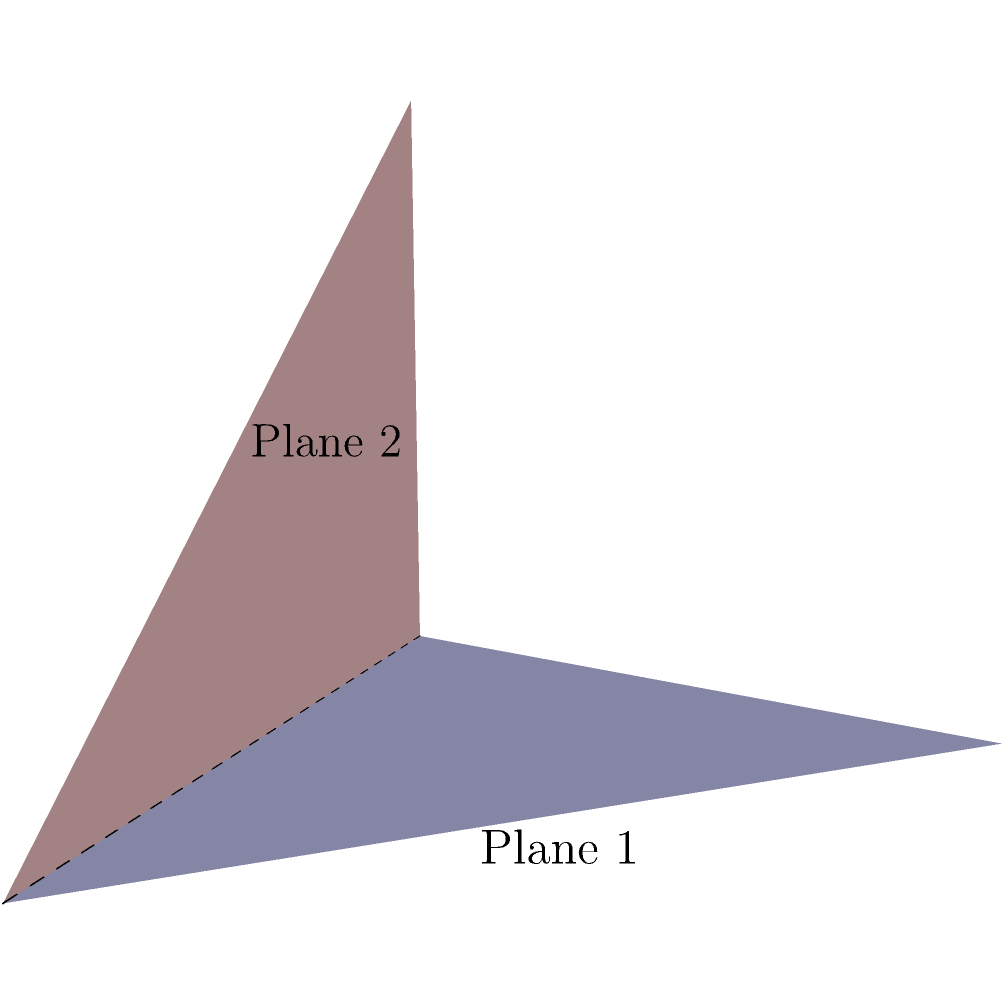In the diagram, two planes intersect along a line. Given that the normal vectors to Plane 1 and Plane 2 are $\vec{n_1} = (0, 0, 1)$ and $\vec{n_2} = (0, 1, 0)$ respectively, determine the angle $\theta$ between these planes. To find the angle between two planes, we can use the dot product formula for the angle between their normal vectors. The steps are as follows:

1) We are given the normal vectors:
   $\vec{n_1} = (0, 0, 1)$ and $\vec{n_2} = (0, 1, 0)$

2) The formula for the angle between two vectors is:
   $$\cos \theta = \frac{\vec{n_1} \cdot \vec{n_2}}{|\vec{n_1}||\vec{n_2}|}$$

3) Calculate the dot product $\vec{n_1} \cdot \vec{n_2}$:
   $(0 \times 0) + (0 \times 1) + (1 \times 0) = 0$

4) Calculate the magnitudes:
   $|\vec{n_1}| = \sqrt{0^2 + 0^2 + 1^2} = 1$
   $|\vec{n_2}| = \sqrt{0^2 + 1^2 + 0^2} = 1$

5) Substitute into the formula:
   $$\cos \theta = \frac{0}{1 \times 1} = 0$$

6) Solve for $\theta$:
   $$\theta = \arccos(0) = \frac{\pi}{2}$$

7) Convert to degrees:
   $$\theta = 90°$$

Therefore, the angle between the two planes is 90°.
Answer: 90° 